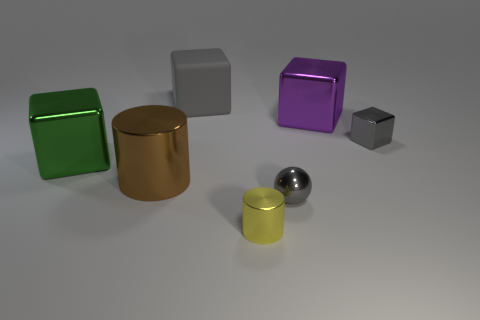Add 1 large red metal balls. How many objects exist? 8 Subtract all blocks. How many objects are left? 3 Subtract 0 green cylinders. How many objects are left? 7 Subtract all small gray shiny balls. Subtract all big purple things. How many objects are left? 5 Add 7 large green metal cubes. How many large green metal cubes are left? 8 Add 5 big gray rubber things. How many big gray rubber things exist? 6 